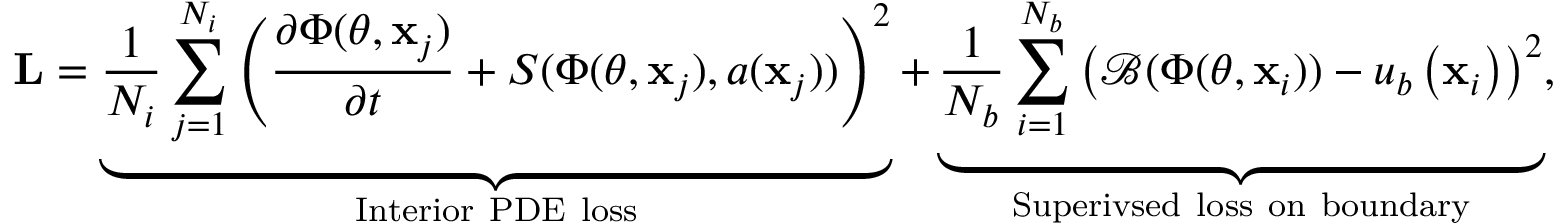<formula> <loc_0><loc_0><loc_500><loc_500>L = \underbrace { \frac { 1 } { N _ { i } } \sum _ { j = 1 } ^ { N _ { i } } \left ( \frac { \partial \Phi ( \theta , x _ { j } ) } { \partial t } + S ( \Phi ( \theta , x _ { j } ) , a ( x _ { j } ) ) \right ) ^ { 2 } } _ { I n t e r i o r P D E l o s s } + \underbrace { \frac { 1 } { N _ { b } } \sum _ { i = 1 } ^ { N _ { b } } \left ( \mathcal { B } ( \Phi ( \theta , x _ { i } ) ) - u _ { b } \left ( x _ { i } \right ) \right ) ^ { 2 } } _ { S u p e r i v s e d l o s s o n b o u n d a r y } ,</formula> 